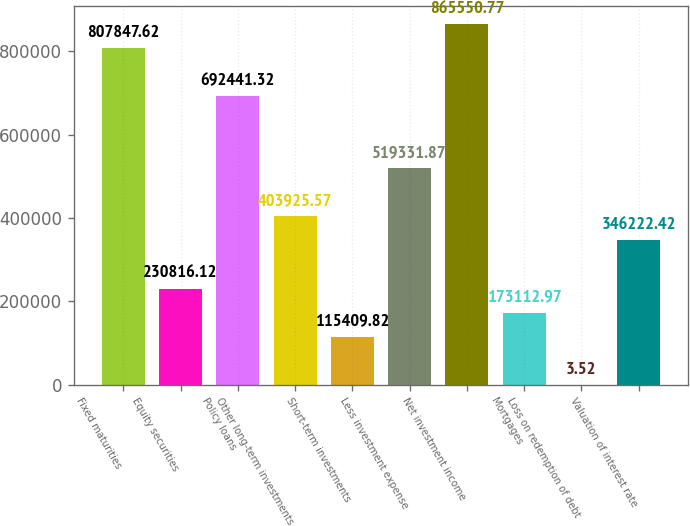Convert chart to OTSL. <chart><loc_0><loc_0><loc_500><loc_500><bar_chart><fcel>Fixed maturities<fcel>Equity securities<fcel>Policy loans<fcel>Other long-term investments<fcel>Short-term investments<fcel>Less investment expense<fcel>Net investment income<fcel>Mortgages<fcel>Loss on redemption of debt<fcel>Valuation of interest rate<nl><fcel>807848<fcel>230816<fcel>692441<fcel>403926<fcel>115410<fcel>519332<fcel>865551<fcel>173113<fcel>3.52<fcel>346222<nl></chart> 